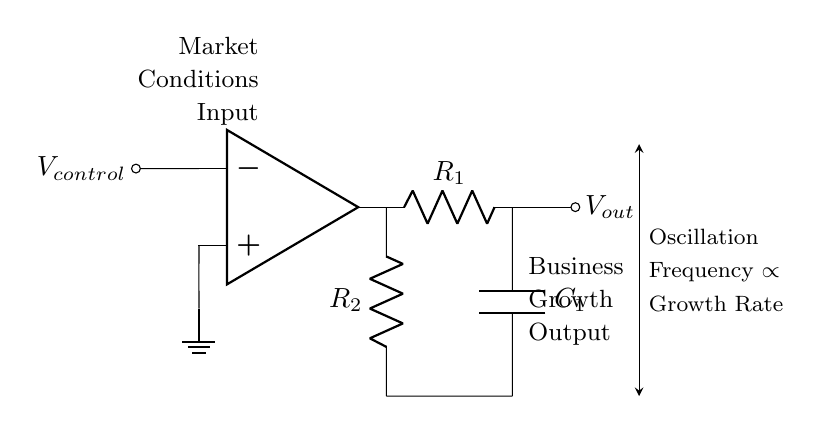what is the primary function of the op amp in this circuit? The op amp serves as a voltage-controlled element that amplifies the input voltage, which in this case simulates control over growth scenarios.
Answer: voltage-controlled amplifier what does the component labeled R1 represent in the circuit? R1 is a resistor that influences the frequency of oscillation by determining the charge and discharge rates of the capacitor, thereby affecting the overall output.
Answer: resistor how does the frequency relate to the control voltage in this circuit? The diagram shows an arrow stating that oscillation frequency is proportional to growth rate, indicating that higher control voltage leads to increased frequency, simulating accelerated growth.
Answer: proportional what is the role of capacitor C1 in the circuit? Capacitor C1 stores electrical energy and affects the timing of the oscillation, influencing how quickly the circuit can respond to changes in control voltage.
Answer: timing what type of circuit is this? The circuit is classified as an oscillator circuit, specifically a voltage-controlled oscillator, as it generates oscillations based on the input control voltage.
Answer: oscillator what effect does adjusting R2 have on the output? Adjusting R2 alters the resistance in the feedback loop of the op amp, which can modify the oscillator's frequency and therefore the simulated business growth output.
Answer: modifies frequency what do the labels 'Market Conditions Input' and 'Business Growth Output' signify? These labels indicate the inputs and outputs of the circuit set in a business context, where market conditions represent control inputs, and output simulates the corresponding growth output.
Answer: input and output 